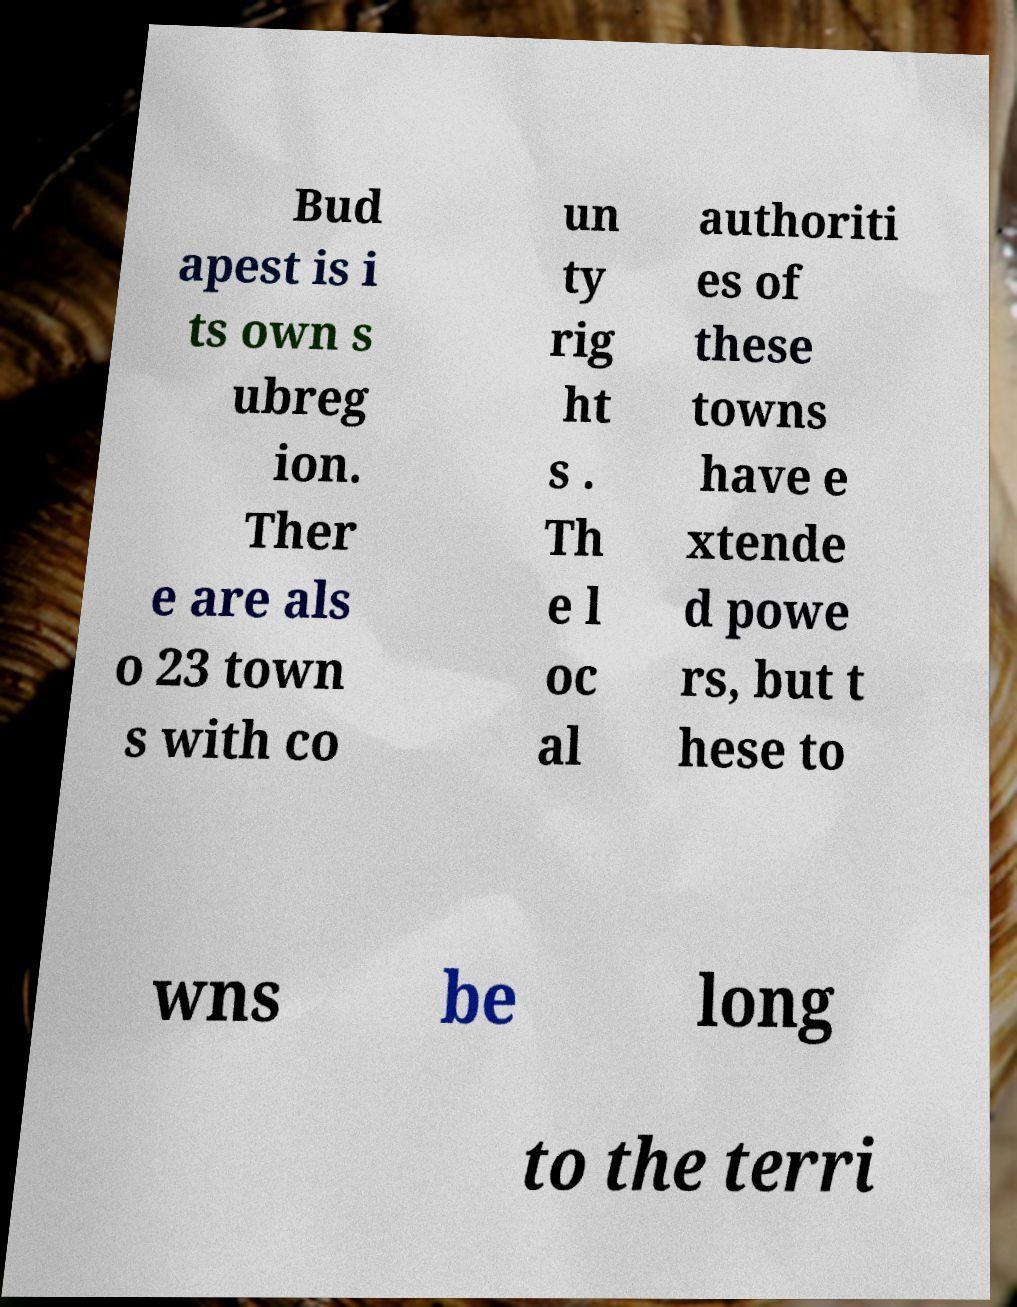There's text embedded in this image that I need extracted. Can you transcribe it verbatim? Bud apest is i ts own s ubreg ion. Ther e are als o 23 town s with co un ty rig ht s . Th e l oc al authoriti es of these towns have e xtende d powe rs, but t hese to wns be long to the terri 